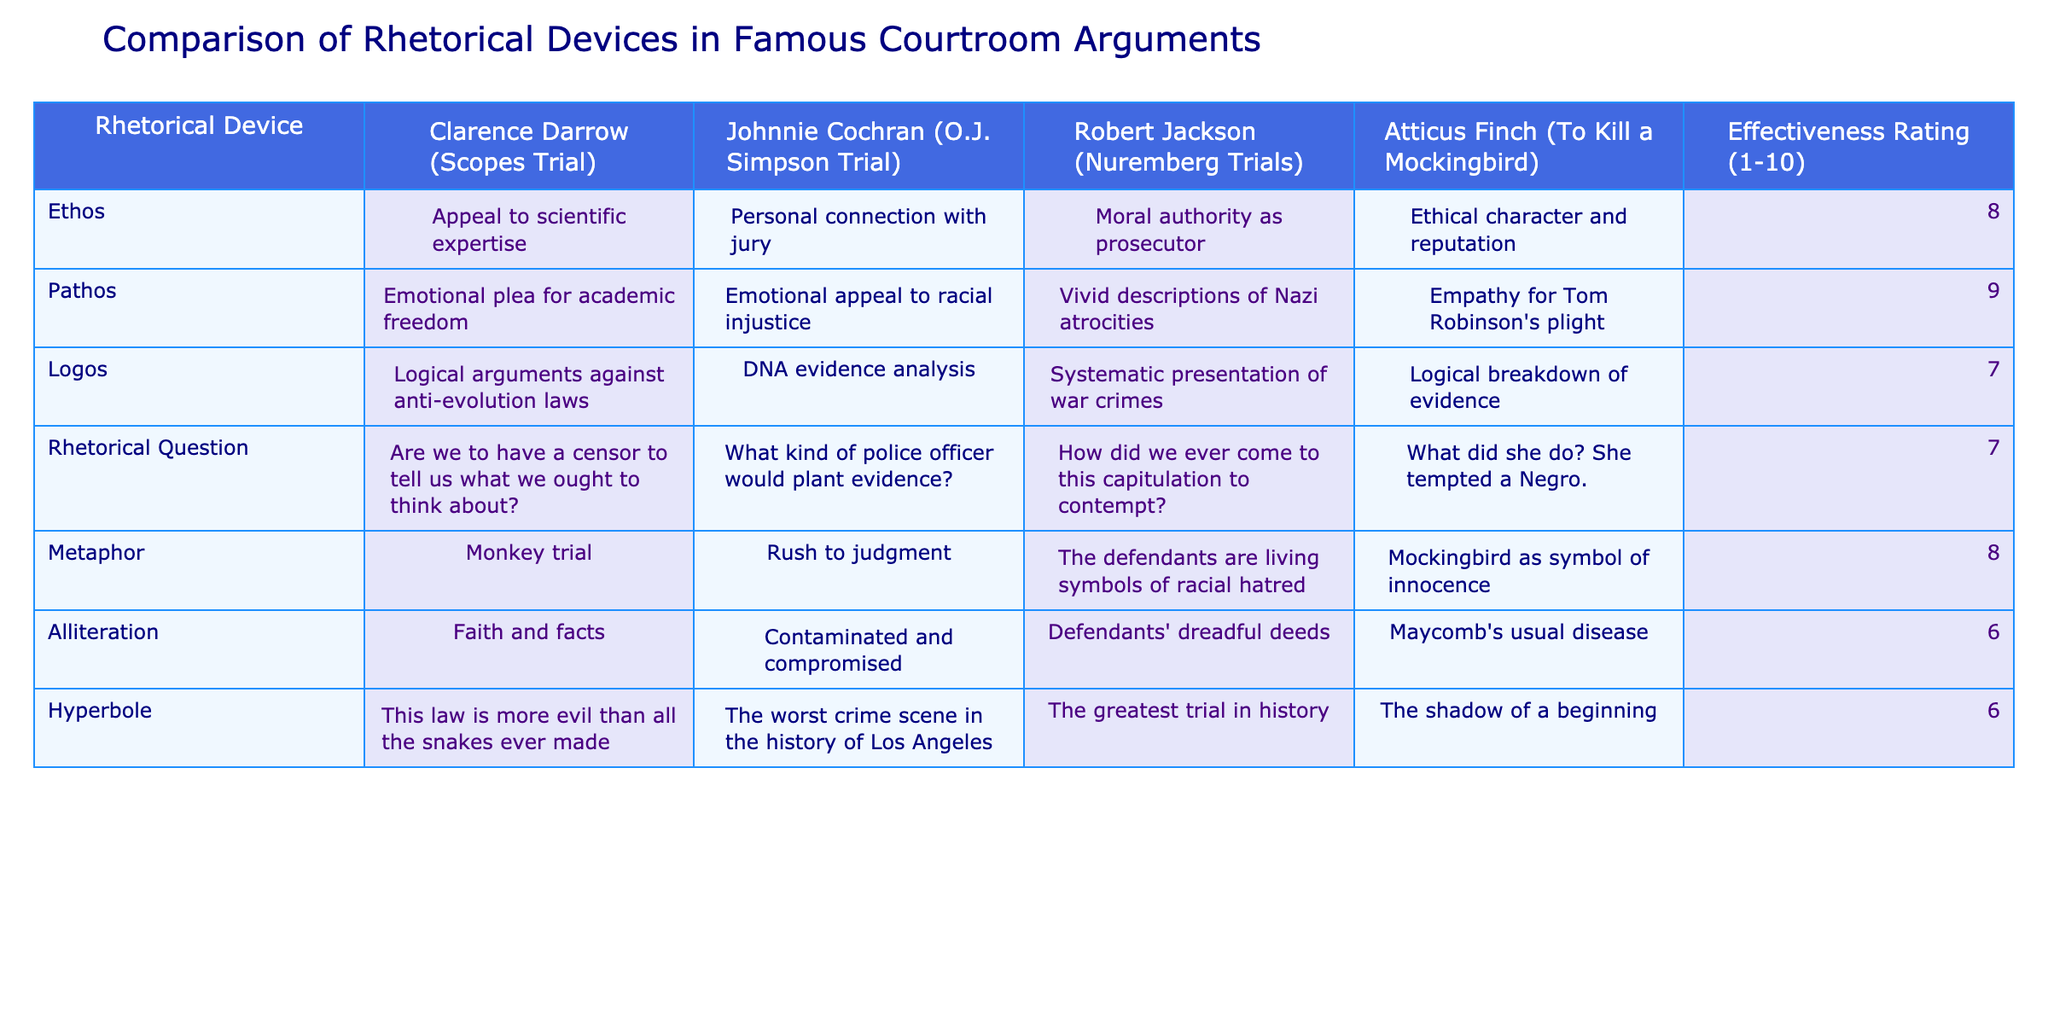What is the effectiveness rating for Ethos used by Johnnie Cochran? The table shows the effectiveness ratings for Ethos, with Johnnie Cochran's rating specifically listed as 8.
Answer: 8 Which rhetorical device received the highest effectiveness rating across all arguments? The effectiveness ratings are compared for each device. Pathos has the highest rating of 9, indicating that it was the most effective device used overall.
Answer: 9 Is there a rhetorical device that both Clarence Darrow and Atticus Finch use that has the same effectiveness rating? By examining the table, we find that both use the metaphor, which has an effectiveness rating of 8 for each of them.
Answer: Yes What is the average effectiveness rating for the rhetorical devices used in this analysis? The effectiveness ratings for all listed rhetorical devices are: 8, 9, 7, 7, 8, 6, and 6. The sum is 51 and there are 7 devices, so the average is 51/7, which equals approximately 7.29.
Answer: 7.29 How many rhetorical devices have an effectiveness rating of 6 or lower? The table lists effectiveness ratings of 6 for alliteration and hyperbole. Therefore, 2 rhetorical devices fall into this category.
Answer: 2 How does the effectiveness of Pathos compare to Logos used by Atticus Finch? The effectiveness rating for Pathos is 9 while the rating for Logos is 7, indicating that Pathos is more effective by 2 points when comparing Atticus Finch's usage.
Answer: Pathos is more effective by 2 points What rhetorical device is linked to moral authority in the context of courtroom arguments? According to the table, the rhetorical device linked to moral authority, especially attributed to Robert Jackson, is Ethos. This is explicitly mentioned as "moral authority as prosecutor."
Answer: Ethos Did Clarence Darrow use the same metaphor as Atticus Finch? The table lists Clarence Darrow's metaphor as "Monkey trial" and Atticus Finch's as "Mockingbird as symbol of innocence." They are different metaphors, so the answer is no.
Answer: No 